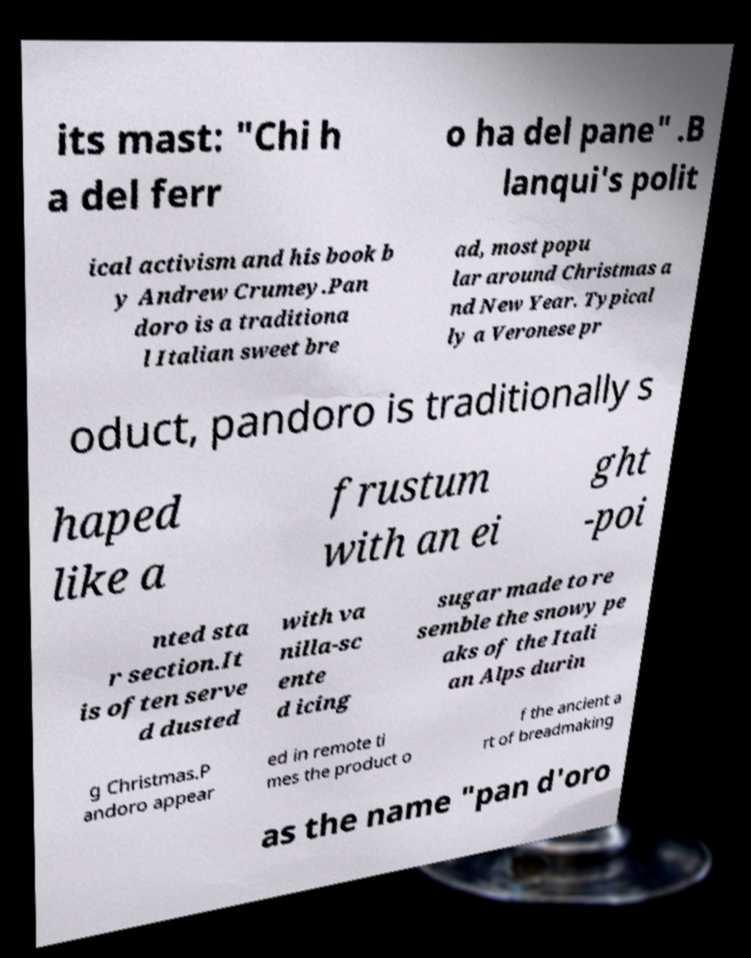Can you accurately transcribe the text from the provided image for me? its mast: "Chi h a del ferr o ha del pane" .B lanqui's polit ical activism and his book b y Andrew Crumey.Pan doro is a traditiona l Italian sweet bre ad, most popu lar around Christmas a nd New Year. Typical ly a Veronese pr oduct, pandoro is traditionally s haped like a frustum with an ei ght -poi nted sta r section.It is often serve d dusted with va nilla-sc ente d icing sugar made to re semble the snowy pe aks of the Itali an Alps durin g Christmas.P andoro appear ed in remote ti mes the product o f the ancient a rt of breadmaking as the name "pan d'oro 